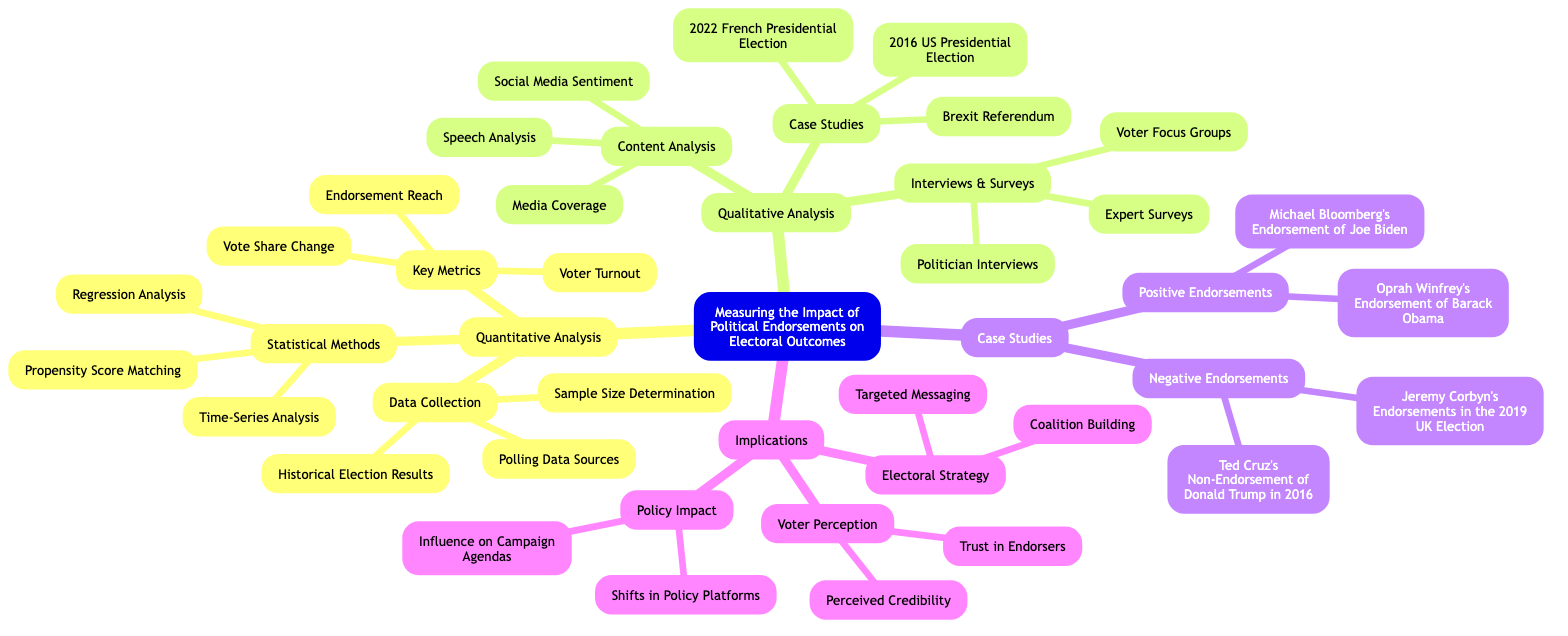What are the three branches of analysis in the diagram? The diagram has three main branches: Quantitative Analysis, Qualitative Analysis, and Case Studies. Each of these branches covers different aspects of measuring the impact of political endorsements on electoral outcomes.
Answer: Quantitative Analysis, Qualitative Analysis, Case Studies How many subbranches does "Qualitative Analysis" have? Under the "Qualitative Analysis" branch, there are three subbranches: Content Analysis, Case Studies, and Interviews & Surveys. Counting these gives a total of three subbranches.
Answer: 3 What key metric is related to the reach of endorsements? The key metric related to the reach of endorsements is "Endorsement Reach," which is listed under the "Key Metrics" subbranch of "Quantitative Analysis."
Answer: Endorsement Reach Which case study involves the 2016 US Presidential Election? The case study related to the 2016 US Presidential Election is specifically mentioned under the "Case Studies" subbranch associated with "Qualitative Analysis."
Answer: 2016 US Presidential Election What is the relationship between "Trust in Endorsers" and "Voter Perception"? "Trust in Endorsers" is a detail listed under the "Voter Perception" subbranch, indicating it is a factor influencing how voters perceive endorsements in the context of electoral outcomes.
Answer: Voter Perception Which statistical method involves analyzing trends over time? The statistical method that involves analyzing trends over time is "Time-Series Analysis," which is part of the "Statistical Methods" subbranch under "Quantitative Analysis."
Answer: Time-Series Analysis What type of endorsement is associated with Oprah Winfrey and Barack Obama? This endorsement is categorized as a "Positive Endorsement," listed under the "Case Studies" branch of the diagram.
Answer: Positive Endorsement How many details are listed under "Content Analysis"? There are three details listed under "Content Analysis": Media Coverage, Speech Analysis, and Social Media Sentiment. This represents the different aspects involved in qualitative scrutiny of endorsements.
Answer: 3 What influences "Shifts in Policy Platforms"? "Shifts in Policy Platforms" is influenced by the "Policy Impact" that is one of the details under "Implications," highlighting its significance in understanding campaign strategies.
Answer: Policy Impact 